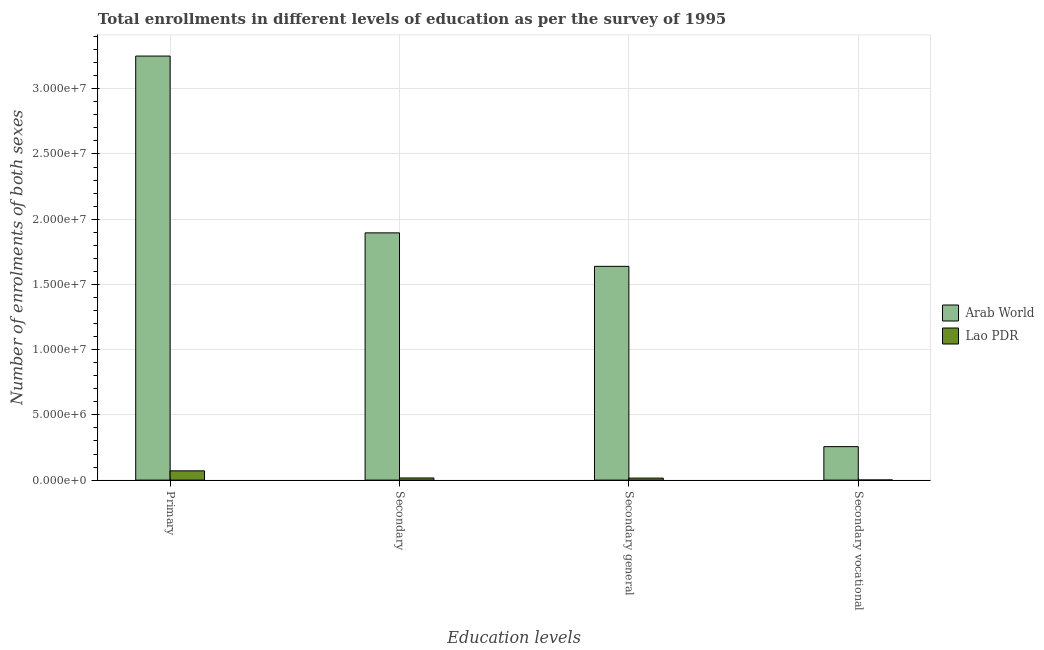How many bars are there on the 3rd tick from the left?
Your answer should be compact. 2. What is the label of the 2nd group of bars from the left?
Provide a short and direct response. Secondary. What is the number of enrolments in secondary general education in Lao PDR?
Your response must be concise. 1.54e+05. Across all countries, what is the maximum number of enrolments in primary education?
Provide a succinct answer. 3.25e+07. Across all countries, what is the minimum number of enrolments in primary education?
Provide a succinct answer. 7.11e+05. In which country was the number of enrolments in secondary education maximum?
Offer a terse response. Arab World. In which country was the number of enrolments in secondary vocational education minimum?
Offer a terse response. Lao PDR. What is the total number of enrolments in secondary general education in the graph?
Your answer should be very brief. 1.65e+07. What is the difference between the number of enrolments in secondary education in Arab World and that in Lao PDR?
Offer a very short reply. 1.88e+07. What is the difference between the number of enrolments in primary education in Arab World and the number of enrolments in secondary education in Lao PDR?
Your response must be concise. 3.23e+07. What is the average number of enrolments in secondary general education per country?
Make the answer very short. 8.27e+06. What is the difference between the number of enrolments in secondary general education and number of enrolments in primary education in Arab World?
Provide a succinct answer. -1.61e+07. What is the ratio of the number of enrolments in secondary education in Arab World to that in Lao PDR?
Ensure brevity in your answer.  115.8. Is the number of enrolments in secondary vocational education in Arab World less than that in Lao PDR?
Provide a succinct answer. No. What is the difference between the highest and the second highest number of enrolments in secondary general education?
Ensure brevity in your answer.  1.62e+07. What is the difference between the highest and the lowest number of enrolments in secondary general education?
Offer a terse response. 1.62e+07. Is the sum of the number of enrolments in secondary education in Lao PDR and Arab World greater than the maximum number of enrolments in secondary vocational education across all countries?
Provide a succinct answer. Yes. Is it the case that in every country, the sum of the number of enrolments in secondary vocational education and number of enrolments in primary education is greater than the sum of number of enrolments in secondary general education and number of enrolments in secondary education?
Keep it short and to the point. No. What does the 1st bar from the left in Primary represents?
Keep it short and to the point. Arab World. What does the 2nd bar from the right in Secondary general represents?
Keep it short and to the point. Arab World. How many bars are there?
Make the answer very short. 8. How many countries are there in the graph?
Make the answer very short. 2. How many legend labels are there?
Provide a short and direct response. 2. How are the legend labels stacked?
Your answer should be compact. Vertical. What is the title of the graph?
Offer a very short reply. Total enrollments in different levels of education as per the survey of 1995. Does "Indonesia" appear as one of the legend labels in the graph?
Give a very brief answer. No. What is the label or title of the X-axis?
Make the answer very short. Education levels. What is the label or title of the Y-axis?
Give a very brief answer. Number of enrolments of both sexes. What is the Number of enrolments of both sexes of Arab World in Primary?
Your response must be concise. 3.25e+07. What is the Number of enrolments of both sexes in Lao PDR in Primary?
Your answer should be very brief. 7.11e+05. What is the Number of enrolments of both sexes in Arab World in Secondary?
Provide a short and direct response. 1.90e+07. What is the Number of enrolments of both sexes in Lao PDR in Secondary?
Ensure brevity in your answer.  1.64e+05. What is the Number of enrolments of both sexes of Arab World in Secondary general?
Keep it short and to the point. 1.64e+07. What is the Number of enrolments of both sexes of Lao PDR in Secondary general?
Keep it short and to the point. 1.54e+05. What is the Number of enrolments of both sexes in Arab World in Secondary vocational?
Your answer should be very brief. 2.57e+06. What is the Number of enrolments of both sexes in Lao PDR in Secondary vocational?
Your answer should be very brief. 9481. Across all Education levels, what is the maximum Number of enrolments of both sexes in Arab World?
Give a very brief answer. 3.25e+07. Across all Education levels, what is the maximum Number of enrolments of both sexes in Lao PDR?
Your answer should be very brief. 7.11e+05. Across all Education levels, what is the minimum Number of enrolments of both sexes of Arab World?
Your response must be concise. 2.57e+06. Across all Education levels, what is the minimum Number of enrolments of both sexes in Lao PDR?
Offer a very short reply. 9481. What is the total Number of enrolments of both sexes in Arab World in the graph?
Give a very brief answer. 7.04e+07. What is the total Number of enrolments of both sexes in Lao PDR in the graph?
Provide a short and direct response. 1.04e+06. What is the difference between the Number of enrolments of both sexes in Arab World in Primary and that in Secondary?
Give a very brief answer. 1.36e+07. What is the difference between the Number of enrolments of both sexes of Lao PDR in Primary and that in Secondary?
Offer a very short reply. 5.47e+05. What is the difference between the Number of enrolments of both sexes of Arab World in Primary and that in Secondary general?
Offer a very short reply. 1.61e+07. What is the difference between the Number of enrolments of both sexes in Lao PDR in Primary and that in Secondary general?
Your response must be concise. 5.57e+05. What is the difference between the Number of enrolments of both sexes of Arab World in Primary and that in Secondary vocational?
Keep it short and to the point. 2.99e+07. What is the difference between the Number of enrolments of both sexes of Lao PDR in Primary and that in Secondary vocational?
Your response must be concise. 7.01e+05. What is the difference between the Number of enrolments of both sexes in Arab World in Secondary and that in Secondary general?
Your response must be concise. 2.57e+06. What is the difference between the Number of enrolments of both sexes in Lao PDR in Secondary and that in Secondary general?
Keep it short and to the point. 9481. What is the difference between the Number of enrolments of both sexes in Arab World in Secondary and that in Secondary vocational?
Give a very brief answer. 1.64e+07. What is the difference between the Number of enrolments of both sexes in Lao PDR in Secondary and that in Secondary vocational?
Make the answer very short. 1.54e+05. What is the difference between the Number of enrolments of both sexes of Arab World in Secondary general and that in Secondary vocational?
Offer a very short reply. 1.38e+07. What is the difference between the Number of enrolments of both sexes in Lao PDR in Secondary general and that in Secondary vocational?
Make the answer very short. 1.45e+05. What is the difference between the Number of enrolments of both sexes in Arab World in Primary and the Number of enrolments of both sexes in Lao PDR in Secondary?
Make the answer very short. 3.23e+07. What is the difference between the Number of enrolments of both sexes of Arab World in Primary and the Number of enrolments of both sexes of Lao PDR in Secondary general?
Provide a short and direct response. 3.23e+07. What is the difference between the Number of enrolments of both sexes of Arab World in Primary and the Number of enrolments of both sexes of Lao PDR in Secondary vocational?
Ensure brevity in your answer.  3.25e+07. What is the difference between the Number of enrolments of both sexes in Arab World in Secondary and the Number of enrolments of both sexes in Lao PDR in Secondary general?
Offer a very short reply. 1.88e+07. What is the difference between the Number of enrolments of both sexes in Arab World in Secondary and the Number of enrolments of both sexes in Lao PDR in Secondary vocational?
Your response must be concise. 1.89e+07. What is the difference between the Number of enrolments of both sexes of Arab World in Secondary general and the Number of enrolments of both sexes of Lao PDR in Secondary vocational?
Make the answer very short. 1.64e+07. What is the average Number of enrolments of both sexes in Arab World per Education levels?
Keep it short and to the point. 1.76e+07. What is the average Number of enrolments of both sexes in Lao PDR per Education levels?
Keep it short and to the point. 2.60e+05. What is the difference between the Number of enrolments of both sexes of Arab World and Number of enrolments of both sexes of Lao PDR in Primary?
Keep it short and to the point. 3.18e+07. What is the difference between the Number of enrolments of both sexes of Arab World and Number of enrolments of both sexes of Lao PDR in Secondary?
Offer a very short reply. 1.88e+07. What is the difference between the Number of enrolments of both sexes in Arab World and Number of enrolments of both sexes in Lao PDR in Secondary general?
Keep it short and to the point. 1.62e+07. What is the difference between the Number of enrolments of both sexes of Arab World and Number of enrolments of both sexes of Lao PDR in Secondary vocational?
Keep it short and to the point. 2.56e+06. What is the ratio of the Number of enrolments of both sexes of Arab World in Primary to that in Secondary?
Offer a very short reply. 1.72. What is the ratio of the Number of enrolments of both sexes in Lao PDR in Primary to that in Secondary?
Provide a succinct answer. 4.34. What is the ratio of the Number of enrolments of both sexes in Arab World in Primary to that in Secondary general?
Ensure brevity in your answer.  1.98. What is the ratio of the Number of enrolments of both sexes in Lao PDR in Primary to that in Secondary general?
Offer a very short reply. 4.61. What is the ratio of the Number of enrolments of both sexes in Arab World in Primary to that in Secondary vocational?
Your answer should be very brief. 12.66. What is the ratio of the Number of enrolments of both sexes in Lao PDR in Primary to that in Secondary vocational?
Offer a very short reply. 74.96. What is the ratio of the Number of enrolments of both sexes of Arab World in Secondary to that in Secondary general?
Make the answer very short. 1.16. What is the ratio of the Number of enrolments of both sexes of Lao PDR in Secondary to that in Secondary general?
Ensure brevity in your answer.  1.06. What is the ratio of the Number of enrolments of both sexes in Arab World in Secondary to that in Secondary vocational?
Offer a terse response. 7.38. What is the ratio of the Number of enrolments of both sexes in Lao PDR in Secondary to that in Secondary vocational?
Your answer should be compact. 17.26. What is the ratio of the Number of enrolments of both sexes of Arab World in Secondary general to that in Secondary vocational?
Your response must be concise. 6.38. What is the ratio of the Number of enrolments of both sexes of Lao PDR in Secondary general to that in Secondary vocational?
Make the answer very short. 16.26. What is the difference between the highest and the second highest Number of enrolments of both sexes of Arab World?
Provide a succinct answer. 1.36e+07. What is the difference between the highest and the second highest Number of enrolments of both sexes of Lao PDR?
Make the answer very short. 5.47e+05. What is the difference between the highest and the lowest Number of enrolments of both sexes in Arab World?
Give a very brief answer. 2.99e+07. What is the difference between the highest and the lowest Number of enrolments of both sexes of Lao PDR?
Keep it short and to the point. 7.01e+05. 